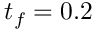<formula> <loc_0><loc_0><loc_500><loc_500>t _ { f } = 0 . 2</formula> 